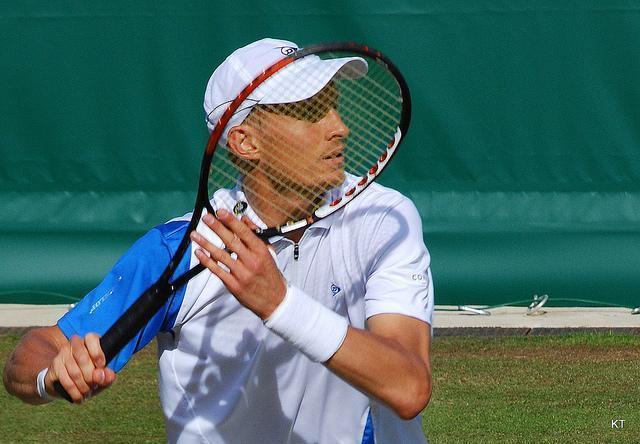How many vehicles have surfboards on top of them?
Give a very brief answer. 0. 